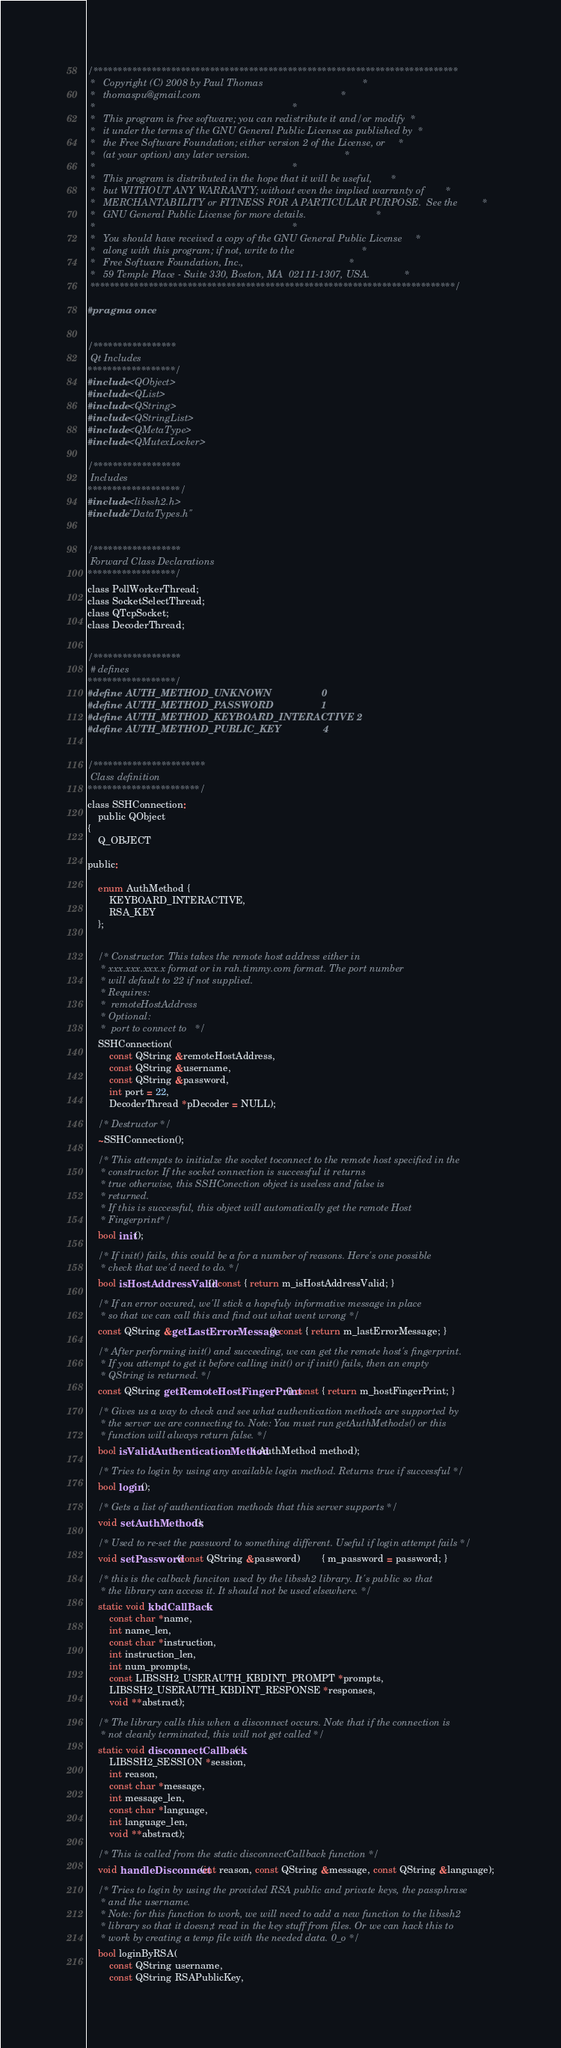Convert code to text. <code><loc_0><loc_0><loc_500><loc_500><_C_>/***************************************************************************
 *   Copyright (C) 2008 by Paul Thomas                                     *
 *   thomaspu@gmail.com                                                    *
 *                                                                         *
 *   This program is free software; you can redistribute it and/or modify  *
 *   it under the terms of the GNU General Public License as published by  *
 *   the Free Software Foundation; either version 2 of the License, or     *
 *   (at your option) any later version.                                   *
 *                                                                         *
 *   This program is distributed in the hope that it will be useful,       *
 *   but WITHOUT ANY WARRANTY; without even the implied warranty of        *
 *   MERCHANTABILITY or FITNESS FOR A PARTICULAR PURPOSE.  See the         *
 *   GNU General Public License for more details.                          *
 *                                                                         *
 *   You should have received a copy of the GNU General Public License     *
 *   along with this program; if not, write to the                         *
 *   Free Software Foundation, Inc.,                                       *
 *   59 Temple Place - Suite 330, Boston, MA  02111-1307, USA.             *
 ***************************************************************************/

#pragma once


/*****************
 Qt Includes
******************/
#include <QObject>
#include <QList>
#include <QString>
#include <QStringList>
#include <QMetaType>
#include <QMutexLocker>

/******************
 Includes
*******************/
#include <libssh2.h>
#include "DataTypes.h"


/******************
 Forward Class Declarations
******************/
class PollWorkerThread;
class SocketSelectThread;
class QTcpSocket;
class DecoderThread;


/******************
 # defines
******************/
#define AUTH_METHOD_UNKNOWN					0
#define AUTH_METHOD_PASSWORD					1
#define AUTH_METHOD_KEYBOARD_INTERACTIVE	2
#define AUTH_METHOD_PUBLIC_KEY				4


/***********************
 Class definition
***********************/
class SSHConnection:
	public QObject
{
	Q_OBJECT 

public:

	enum AuthMethod {
		KEYBOARD_INTERACTIVE,
		RSA_KEY
	};


	/* Constructor. This takes the remote host address either in
	 * xxx.xxx.xxx.x format or in rah.timmy.com format. The port number
	 * will default to 22 if not supplied.
	 * Requires:
	 *	remoteHostAddress
	 * Optional:
	 *	port to connect to	 */
	SSHConnection(
		const QString &remoteHostAddress,
		const QString &username,
		const QString &password,
		int port = 22,
		DecoderThread *pDecoder = NULL);
	
	/* Destructor */
	~SSHConnection();

	/* This attempts to initialze the socket toconnect to the remote host specified in the
	 * constructor. If the socket connection is successful it returns
	 * true otherwise, this SSHConection object is useless and false is
	 * returned.
	 * If this is successful, this object will automatically get the remote Host 
	 * Fingerprint*/
	bool init();
	
	/* If init() fails, this could be a for a number of reasons. Here's one possible
	 * check that we'd need to do. */
	bool isHostAddressValid() const { return m_isHostAddressValid; }

	/* If an error occured, we'll stick a hopefuly informative message in place
	 * so that we can call this and find out what went wrong */
	const QString &getLastErrorMessage() const { return m_lastErrorMessage; }

	/* After performing init() and succeeding, we can get the remote host's fingerprint.
	 * If you attempt to get it before calling init() or if init() fails, then an empty
	 * QString is returned. */
	const QString getRemoteHostFingerPrint() const { return m_hostFingerPrint; }

	/* Gives us a way to check and see what authentication methods are supported by
	 * the server we are connecting to. Note: You must run getAuthMethods() or this
	 * function will always return false. */
	bool isValidAuthenticationMethod( AuthMethod method);

	/* Tries to login by using any available login method. Returns true if successful */
	bool login();

	/* Gets a list of authentication methods that this server supports */
	void setAuthMethods();

	/* Used to re-set the password to something different. Useful if login attempt fails */
	void setPassword(const QString &password)		{ m_password = password; }

	/* this is the calback funciton used by the libssh2 library. It's public so that
	 * the library can access it. It should not be used elsewhere. */
	static void kbdCallBack(
		const char *name,
		int name_len, 
		const char *instruction,
		int instruction_len,
		int num_prompts,
		const LIBSSH2_USERAUTH_KBDINT_PROMPT *prompts,
		LIBSSH2_USERAUTH_KBDINT_RESPONSE *responses,
		void **abstract);

	/* The library calls this when a disconnect occurs. Note that if the connection is
	 * not cleanly terminated, this will not get called */
	static void disconnectCallback(
		LIBSSH2_SESSION *session,
		int reason,
		const char *message,
		int message_len,
		const char *language,
		int language_len,
		void **abstract);

	/* This is called from the static disconnectCallback function */
	void handleDisconnect(int reason, const QString &message, const QString &language);

	/* Tries to login by using the provided RSA public and private keys, the passphrase
	 * and the username. 
	 * Note: for this function to work, we will need to add a new function to the libssh2
	 * library so that it doesn;t read in the key stuff from files. Or we can hack this to
	 * work by creating a temp file with the needed data. 0_o */
	bool loginByRSA(
		const QString username,
		const QString RSAPublicKey,</code> 